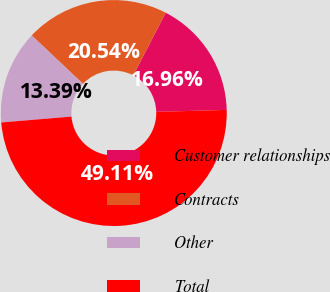Convert chart. <chart><loc_0><loc_0><loc_500><loc_500><pie_chart><fcel>Customer relationships<fcel>Contracts<fcel>Other<fcel>Total<nl><fcel>16.96%<fcel>20.54%<fcel>13.39%<fcel>49.11%<nl></chart> 